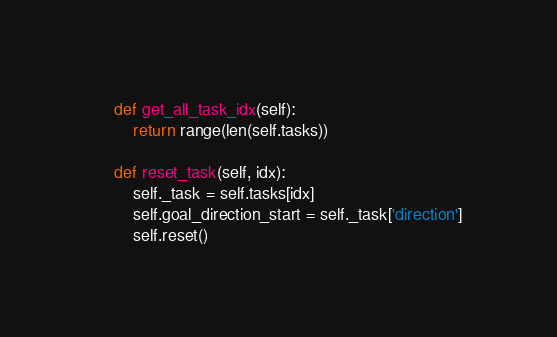Convert code to text. <code><loc_0><loc_0><loc_500><loc_500><_Python_>    def get_all_task_idx(self):
        return range(len(self.tasks))

    def reset_task(self, idx):
        self._task = self.tasks[idx]
        self.goal_direction_start = self._task['direction']
        self.reset()</code> 